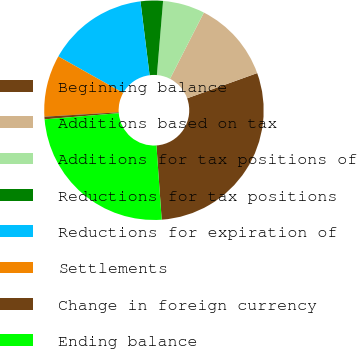Convert chart. <chart><loc_0><loc_0><loc_500><loc_500><pie_chart><fcel>Beginning balance<fcel>Additions based on tax<fcel>Additions for tax positions of<fcel>Reductions for tax positions<fcel>Reductions for expiration of<fcel>Settlements<fcel>Change in foreign currency<fcel>Ending balance<nl><fcel>29.37%<fcel>11.98%<fcel>6.19%<fcel>3.29%<fcel>14.88%<fcel>9.09%<fcel>0.39%<fcel>24.8%<nl></chart> 